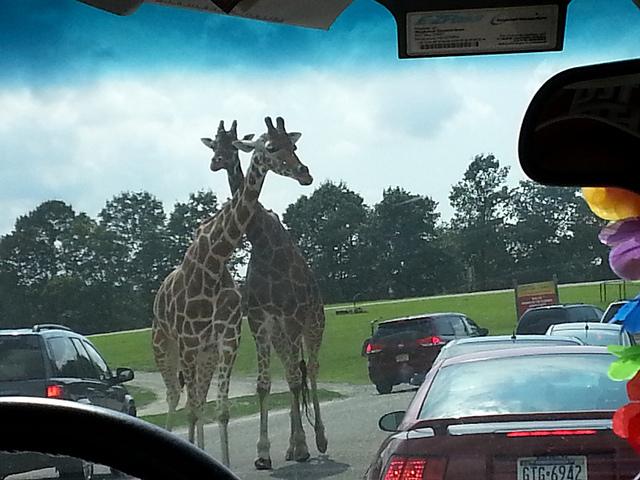How many giraffes are there?
Be succinct. 2. Is it cloudy?
Keep it brief. Yes. What are these animals?
Concise answer only. Giraffes. 